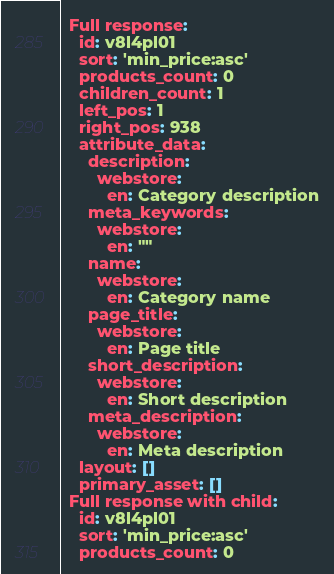<code> <loc_0><loc_0><loc_500><loc_500><_YAML_>  Full response:
    id: v8l4pl01
    sort: 'min_price:asc'
    products_count: 0
    children_count: 1
    left_pos: 1
    right_pos: 938
    attribute_data:
      description:
        webstore:
          en: Category description
      meta_keywords:
        webstore:
          en: ""
      name:
        webstore:
          en: Category name
      page_title:
        webstore:
          en: Page title
      short_description:
        webstore:
          en: Short description
      meta_description:
        webstore:
          en: Meta description
    layout: []
    primary_asset: []
  Full response with child:
    id: v8l4pl01
    sort: 'min_price:asc'
    products_count: 0</code> 